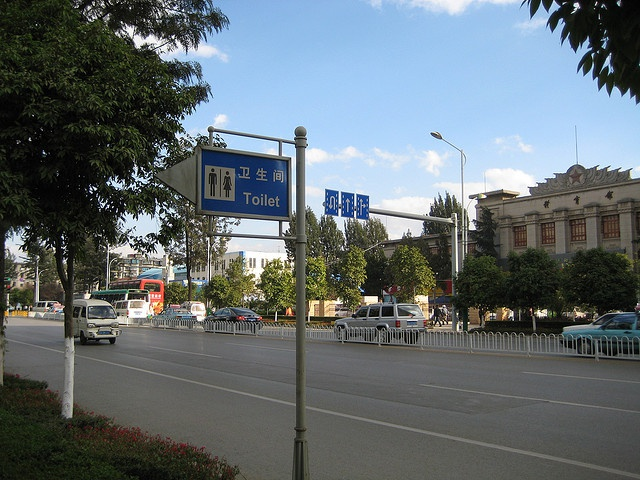Describe the objects in this image and their specific colors. I can see car in black, gray, teal, and darkblue tones, car in black, gray, and darkgray tones, truck in black, gray, darkgray, and beige tones, bus in black, white, gray, and darkgray tones, and bus in black, salmon, gray, and darkgreen tones in this image. 